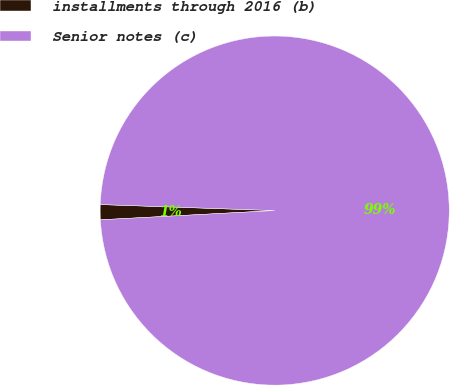Convert chart to OTSL. <chart><loc_0><loc_0><loc_500><loc_500><pie_chart><fcel>installments through 2016 (b)<fcel>Senior notes (c)<nl><fcel>1.39%<fcel>98.61%<nl></chart> 